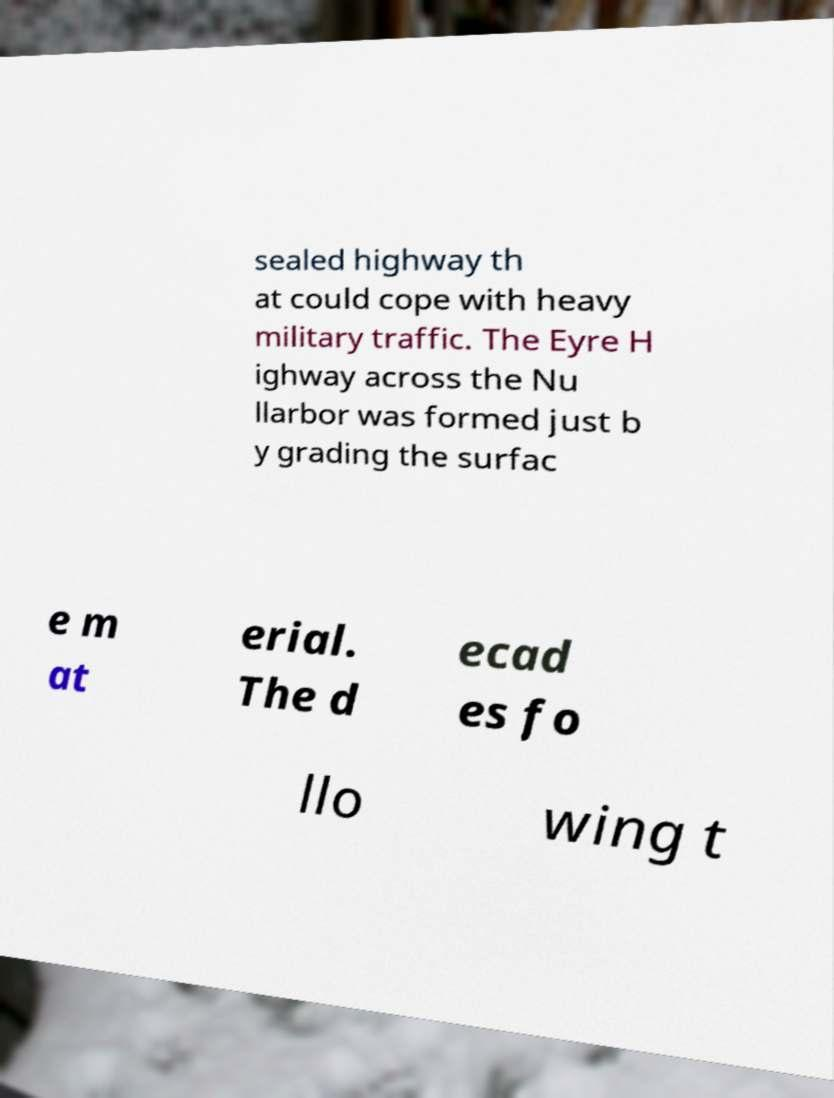There's text embedded in this image that I need extracted. Can you transcribe it verbatim? sealed highway th at could cope with heavy military traffic. The Eyre H ighway across the Nu llarbor was formed just b y grading the surfac e m at erial. The d ecad es fo llo wing t 